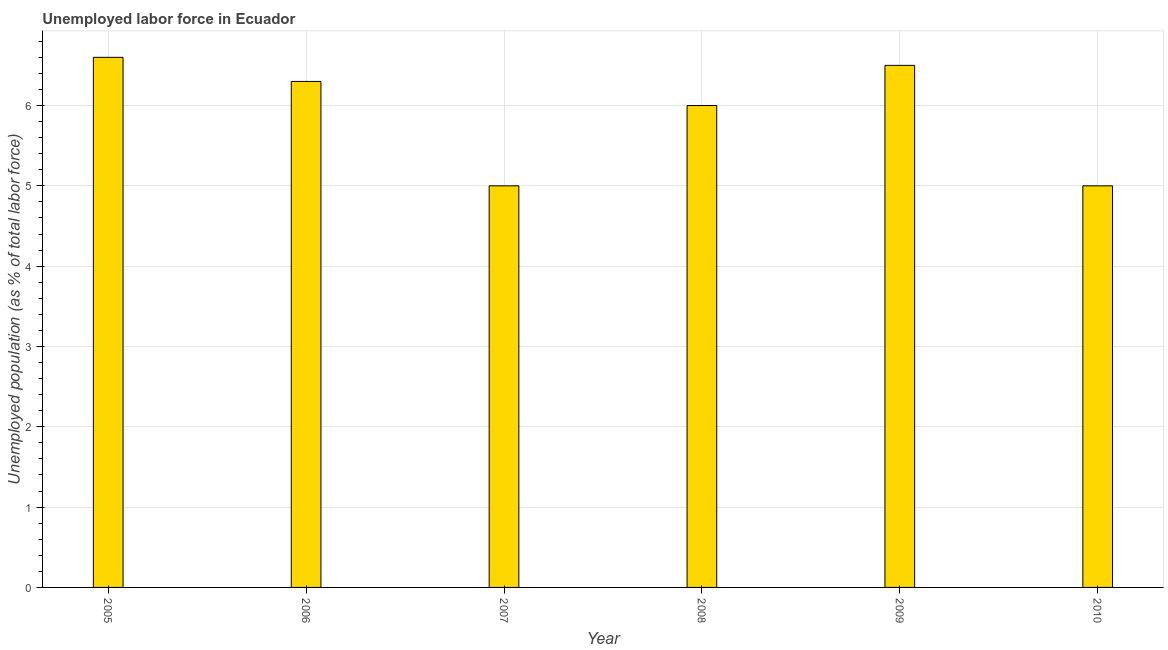Does the graph contain any zero values?
Your answer should be very brief. No. Does the graph contain grids?
Your answer should be very brief. Yes. What is the title of the graph?
Your response must be concise. Unemployed labor force in Ecuador. What is the label or title of the X-axis?
Your answer should be very brief. Year. What is the label or title of the Y-axis?
Your answer should be very brief. Unemployed population (as % of total labor force). Across all years, what is the maximum total unemployed population?
Make the answer very short. 6.6. Across all years, what is the minimum total unemployed population?
Keep it short and to the point. 5. In which year was the total unemployed population maximum?
Keep it short and to the point. 2005. What is the sum of the total unemployed population?
Ensure brevity in your answer.  35.4. What is the difference between the total unemployed population in 2005 and 2009?
Keep it short and to the point. 0.1. What is the median total unemployed population?
Your answer should be compact. 6.15. Is the total unemployed population in 2005 less than that in 2007?
Offer a terse response. No. What is the difference between the highest and the second highest total unemployed population?
Your answer should be very brief. 0.1. Are all the bars in the graph horizontal?
Give a very brief answer. No. How many years are there in the graph?
Offer a very short reply. 6. What is the difference between two consecutive major ticks on the Y-axis?
Keep it short and to the point. 1. What is the Unemployed population (as % of total labor force) of 2005?
Provide a succinct answer. 6.6. What is the Unemployed population (as % of total labor force) of 2006?
Keep it short and to the point. 6.3. What is the Unemployed population (as % of total labor force) in 2007?
Offer a very short reply. 5. What is the Unemployed population (as % of total labor force) of 2008?
Provide a short and direct response. 6. What is the difference between the Unemployed population (as % of total labor force) in 2005 and 2006?
Give a very brief answer. 0.3. What is the difference between the Unemployed population (as % of total labor force) in 2005 and 2008?
Give a very brief answer. 0.6. What is the difference between the Unemployed population (as % of total labor force) in 2005 and 2009?
Keep it short and to the point. 0.1. What is the difference between the Unemployed population (as % of total labor force) in 2006 and 2007?
Offer a very short reply. 1.3. What is the difference between the Unemployed population (as % of total labor force) in 2007 and 2008?
Your answer should be very brief. -1. What is the difference between the Unemployed population (as % of total labor force) in 2009 and 2010?
Ensure brevity in your answer.  1.5. What is the ratio of the Unemployed population (as % of total labor force) in 2005 to that in 2006?
Provide a succinct answer. 1.05. What is the ratio of the Unemployed population (as % of total labor force) in 2005 to that in 2007?
Provide a short and direct response. 1.32. What is the ratio of the Unemployed population (as % of total labor force) in 2005 to that in 2009?
Keep it short and to the point. 1.01. What is the ratio of the Unemployed population (as % of total labor force) in 2005 to that in 2010?
Offer a very short reply. 1.32. What is the ratio of the Unemployed population (as % of total labor force) in 2006 to that in 2007?
Offer a terse response. 1.26. What is the ratio of the Unemployed population (as % of total labor force) in 2006 to that in 2009?
Your response must be concise. 0.97. What is the ratio of the Unemployed population (as % of total labor force) in 2006 to that in 2010?
Provide a succinct answer. 1.26. What is the ratio of the Unemployed population (as % of total labor force) in 2007 to that in 2008?
Give a very brief answer. 0.83. What is the ratio of the Unemployed population (as % of total labor force) in 2007 to that in 2009?
Give a very brief answer. 0.77. What is the ratio of the Unemployed population (as % of total labor force) in 2008 to that in 2009?
Provide a succinct answer. 0.92. What is the ratio of the Unemployed population (as % of total labor force) in 2009 to that in 2010?
Make the answer very short. 1.3. 